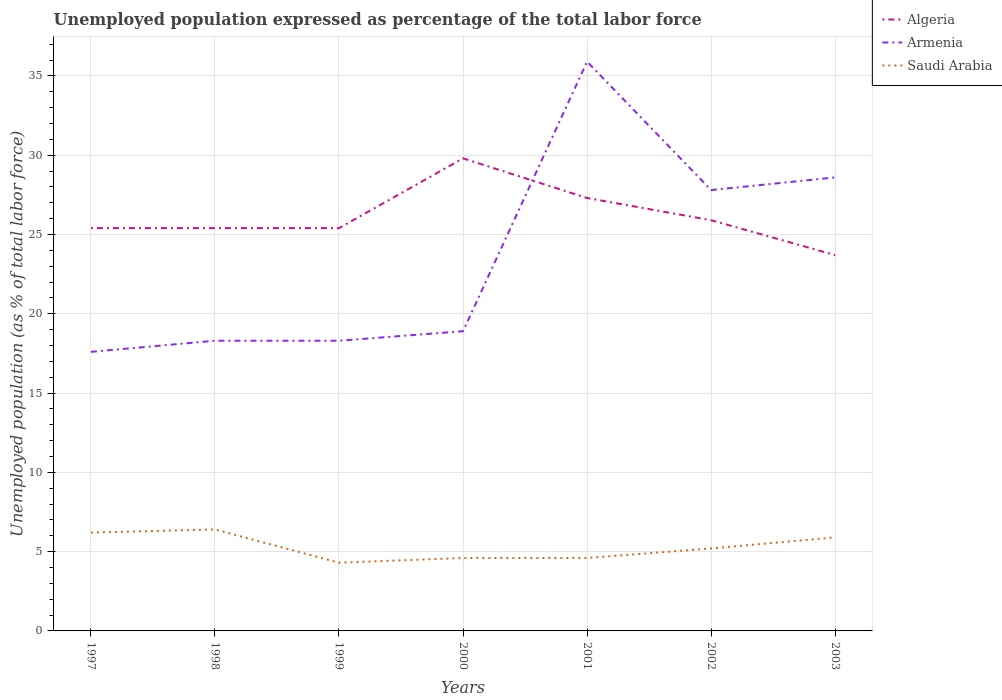Is the number of lines equal to the number of legend labels?
Give a very brief answer. Yes. Across all years, what is the maximum unemployment in in Algeria?
Offer a terse response. 23.7. What is the total unemployment in in Saudi Arabia in the graph?
Ensure brevity in your answer.  1. What is the difference between the highest and the second highest unemployment in in Saudi Arabia?
Make the answer very short. 2.1. How many lines are there?
Keep it short and to the point. 3. Where does the legend appear in the graph?
Ensure brevity in your answer.  Top right. How are the legend labels stacked?
Provide a short and direct response. Vertical. What is the title of the graph?
Make the answer very short. Unemployed population expressed as percentage of the total labor force. Does "Solomon Islands" appear as one of the legend labels in the graph?
Keep it short and to the point. No. What is the label or title of the Y-axis?
Offer a very short reply. Unemployed population (as % of total labor force). What is the Unemployed population (as % of total labor force) in Algeria in 1997?
Your answer should be compact. 25.4. What is the Unemployed population (as % of total labor force) of Armenia in 1997?
Make the answer very short. 17.6. What is the Unemployed population (as % of total labor force) of Saudi Arabia in 1997?
Make the answer very short. 6.2. What is the Unemployed population (as % of total labor force) of Algeria in 1998?
Keep it short and to the point. 25.4. What is the Unemployed population (as % of total labor force) of Armenia in 1998?
Your response must be concise. 18.3. What is the Unemployed population (as % of total labor force) of Saudi Arabia in 1998?
Provide a short and direct response. 6.4. What is the Unemployed population (as % of total labor force) of Algeria in 1999?
Your answer should be very brief. 25.4. What is the Unemployed population (as % of total labor force) of Armenia in 1999?
Your answer should be very brief. 18.3. What is the Unemployed population (as % of total labor force) in Saudi Arabia in 1999?
Make the answer very short. 4.3. What is the Unemployed population (as % of total labor force) in Algeria in 2000?
Offer a very short reply. 29.8. What is the Unemployed population (as % of total labor force) of Armenia in 2000?
Keep it short and to the point. 18.9. What is the Unemployed population (as % of total labor force) in Saudi Arabia in 2000?
Offer a terse response. 4.6. What is the Unemployed population (as % of total labor force) in Algeria in 2001?
Make the answer very short. 27.3. What is the Unemployed population (as % of total labor force) in Armenia in 2001?
Your answer should be very brief. 35.9. What is the Unemployed population (as % of total labor force) of Saudi Arabia in 2001?
Your response must be concise. 4.6. What is the Unemployed population (as % of total labor force) in Algeria in 2002?
Keep it short and to the point. 25.9. What is the Unemployed population (as % of total labor force) in Armenia in 2002?
Your answer should be very brief. 27.8. What is the Unemployed population (as % of total labor force) of Saudi Arabia in 2002?
Provide a succinct answer. 5.2. What is the Unemployed population (as % of total labor force) in Algeria in 2003?
Give a very brief answer. 23.7. What is the Unemployed population (as % of total labor force) in Armenia in 2003?
Offer a terse response. 28.6. What is the Unemployed population (as % of total labor force) in Saudi Arabia in 2003?
Make the answer very short. 5.9. Across all years, what is the maximum Unemployed population (as % of total labor force) of Algeria?
Give a very brief answer. 29.8. Across all years, what is the maximum Unemployed population (as % of total labor force) in Armenia?
Make the answer very short. 35.9. Across all years, what is the maximum Unemployed population (as % of total labor force) in Saudi Arabia?
Your answer should be very brief. 6.4. Across all years, what is the minimum Unemployed population (as % of total labor force) in Algeria?
Your answer should be very brief. 23.7. Across all years, what is the minimum Unemployed population (as % of total labor force) of Armenia?
Your answer should be compact. 17.6. Across all years, what is the minimum Unemployed population (as % of total labor force) of Saudi Arabia?
Ensure brevity in your answer.  4.3. What is the total Unemployed population (as % of total labor force) in Algeria in the graph?
Your answer should be compact. 182.9. What is the total Unemployed population (as % of total labor force) in Armenia in the graph?
Make the answer very short. 165.4. What is the total Unemployed population (as % of total labor force) of Saudi Arabia in the graph?
Give a very brief answer. 37.2. What is the difference between the Unemployed population (as % of total labor force) in Armenia in 1997 and that in 1998?
Offer a terse response. -0.7. What is the difference between the Unemployed population (as % of total labor force) of Saudi Arabia in 1997 and that in 1998?
Provide a succinct answer. -0.2. What is the difference between the Unemployed population (as % of total labor force) in Saudi Arabia in 1997 and that in 1999?
Your answer should be compact. 1.9. What is the difference between the Unemployed population (as % of total labor force) in Algeria in 1997 and that in 2000?
Offer a terse response. -4.4. What is the difference between the Unemployed population (as % of total labor force) of Armenia in 1997 and that in 2000?
Keep it short and to the point. -1.3. What is the difference between the Unemployed population (as % of total labor force) of Saudi Arabia in 1997 and that in 2000?
Provide a succinct answer. 1.6. What is the difference between the Unemployed population (as % of total labor force) in Armenia in 1997 and that in 2001?
Your response must be concise. -18.3. What is the difference between the Unemployed population (as % of total labor force) of Saudi Arabia in 1997 and that in 2001?
Keep it short and to the point. 1.6. What is the difference between the Unemployed population (as % of total labor force) of Algeria in 1997 and that in 2002?
Give a very brief answer. -0.5. What is the difference between the Unemployed population (as % of total labor force) of Algeria in 1997 and that in 2003?
Your answer should be compact. 1.7. What is the difference between the Unemployed population (as % of total labor force) in Algeria in 1998 and that in 2000?
Your response must be concise. -4.4. What is the difference between the Unemployed population (as % of total labor force) in Armenia in 1998 and that in 2001?
Provide a succinct answer. -17.6. What is the difference between the Unemployed population (as % of total labor force) of Algeria in 1998 and that in 2002?
Keep it short and to the point. -0.5. What is the difference between the Unemployed population (as % of total labor force) in Armenia in 1998 and that in 2002?
Your answer should be compact. -9.5. What is the difference between the Unemployed population (as % of total labor force) of Saudi Arabia in 1998 and that in 2002?
Ensure brevity in your answer.  1.2. What is the difference between the Unemployed population (as % of total labor force) of Armenia in 1998 and that in 2003?
Keep it short and to the point. -10.3. What is the difference between the Unemployed population (as % of total labor force) of Saudi Arabia in 1998 and that in 2003?
Offer a terse response. 0.5. What is the difference between the Unemployed population (as % of total labor force) in Algeria in 1999 and that in 2001?
Your response must be concise. -1.9. What is the difference between the Unemployed population (as % of total labor force) in Armenia in 1999 and that in 2001?
Give a very brief answer. -17.6. What is the difference between the Unemployed population (as % of total labor force) in Saudi Arabia in 1999 and that in 2001?
Offer a terse response. -0.3. What is the difference between the Unemployed population (as % of total labor force) of Armenia in 1999 and that in 2002?
Ensure brevity in your answer.  -9.5. What is the difference between the Unemployed population (as % of total labor force) of Saudi Arabia in 1999 and that in 2002?
Your answer should be compact. -0.9. What is the difference between the Unemployed population (as % of total labor force) of Algeria in 2000 and that in 2001?
Make the answer very short. 2.5. What is the difference between the Unemployed population (as % of total labor force) in Armenia in 2000 and that in 2001?
Provide a short and direct response. -17. What is the difference between the Unemployed population (as % of total labor force) in Algeria in 2000 and that in 2002?
Offer a very short reply. 3.9. What is the difference between the Unemployed population (as % of total labor force) in Armenia in 2000 and that in 2002?
Your answer should be very brief. -8.9. What is the difference between the Unemployed population (as % of total labor force) in Algeria in 2000 and that in 2003?
Your answer should be very brief. 6.1. What is the difference between the Unemployed population (as % of total labor force) of Saudi Arabia in 2000 and that in 2003?
Your answer should be compact. -1.3. What is the difference between the Unemployed population (as % of total labor force) of Algeria in 2001 and that in 2002?
Offer a terse response. 1.4. What is the difference between the Unemployed population (as % of total labor force) of Saudi Arabia in 2001 and that in 2002?
Your answer should be very brief. -0.6. What is the difference between the Unemployed population (as % of total labor force) of Armenia in 2001 and that in 2003?
Provide a succinct answer. 7.3. What is the difference between the Unemployed population (as % of total labor force) of Algeria in 1997 and the Unemployed population (as % of total labor force) of Armenia in 1998?
Ensure brevity in your answer.  7.1. What is the difference between the Unemployed population (as % of total labor force) of Algeria in 1997 and the Unemployed population (as % of total labor force) of Armenia in 1999?
Offer a very short reply. 7.1. What is the difference between the Unemployed population (as % of total labor force) in Algeria in 1997 and the Unemployed population (as % of total labor force) in Saudi Arabia in 1999?
Give a very brief answer. 21.1. What is the difference between the Unemployed population (as % of total labor force) of Algeria in 1997 and the Unemployed population (as % of total labor force) of Saudi Arabia in 2000?
Make the answer very short. 20.8. What is the difference between the Unemployed population (as % of total labor force) in Armenia in 1997 and the Unemployed population (as % of total labor force) in Saudi Arabia in 2000?
Keep it short and to the point. 13. What is the difference between the Unemployed population (as % of total labor force) in Algeria in 1997 and the Unemployed population (as % of total labor force) in Saudi Arabia in 2001?
Offer a very short reply. 20.8. What is the difference between the Unemployed population (as % of total labor force) of Algeria in 1997 and the Unemployed population (as % of total labor force) of Saudi Arabia in 2002?
Your answer should be very brief. 20.2. What is the difference between the Unemployed population (as % of total labor force) in Algeria in 1997 and the Unemployed population (as % of total labor force) in Saudi Arabia in 2003?
Offer a very short reply. 19.5. What is the difference between the Unemployed population (as % of total labor force) in Algeria in 1998 and the Unemployed population (as % of total labor force) in Armenia in 1999?
Your answer should be very brief. 7.1. What is the difference between the Unemployed population (as % of total labor force) in Algeria in 1998 and the Unemployed population (as % of total labor force) in Saudi Arabia in 1999?
Offer a terse response. 21.1. What is the difference between the Unemployed population (as % of total labor force) of Algeria in 1998 and the Unemployed population (as % of total labor force) of Saudi Arabia in 2000?
Your answer should be compact. 20.8. What is the difference between the Unemployed population (as % of total labor force) in Armenia in 1998 and the Unemployed population (as % of total labor force) in Saudi Arabia in 2000?
Give a very brief answer. 13.7. What is the difference between the Unemployed population (as % of total labor force) of Algeria in 1998 and the Unemployed population (as % of total labor force) of Armenia in 2001?
Ensure brevity in your answer.  -10.5. What is the difference between the Unemployed population (as % of total labor force) in Algeria in 1998 and the Unemployed population (as % of total labor force) in Saudi Arabia in 2001?
Your response must be concise. 20.8. What is the difference between the Unemployed population (as % of total labor force) in Armenia in 1998 and the Unemployed population (as % of total labor force) in Saudi Arabia in 2001?
Offer a terse response. 13.7. What is the difference between the Unemployed population (as % of total labor force) of Algeria in 1998 and the Unemployed population (as % of total labor force) of Armenia in 2002?
Your response must be concise. -2.4. What is the difference between the Unemployed population (as % of total labor force) in Algeria in 1998 and the Unemployed population (as % of total labor force) in Saudi Arabia in 2002?
Provide a succinct answer. 20.2. What is the difference between the Unemployed population (as % of total labor force) of Algeria in 1998 and the Unemployed population (as % of total labor force) of Armenia in 2003?
Keep it short and to the point. -3.2. What is the difference between the Unemployed population (as % of total labor force) in Algeria in 1998 and the Unemployed population (as % of total labor force) in Saudi Arabia in 2003?
Keep it short and to the point. 19.5. What is the difference between the Unemployed population (as % of total labor force) in Armenia in 1998 and the Unemployed population (as % of total labor force) in Saudi Arabia in 2003?
Keep it short and to the point. 12.4. What is the difference between the Unemployed population (as % of total labor force) of Algeria in 1999 and the Unemployed population (as % of total labor force) of Saudi Arabia in 2000?
Give a very brief answer. 20.8. What is the difference between the Unemployed population (as % of total labor force) of Armenia in 1999 and the Unemployed population (as % of total labor force) of Saudi Arabia in 2000?
Offer a very short reply. 13.7. What is the difference between the Unemployed population (as % of total labor force) in Algeria in 1999 and the Unemployed population (as % of total labor force) in Armenia in 2001?
Provide a short and direct response. -10.5. What is the difference between the Unemployed population (as % of total labor force) in Algeria in 1999 and the Unemployed population (as % of total labor force) in Saudi Arabia in 2001?
Provide a short and direct response. 20.8. What is the difference between the Unemployed population (as % of total labor force) of Algeria in 1999 and the Unemployed population (as % of total labor force) of Saudi Arabia in 2002?
Give a very brief answer. 20.2. What is the difference between the Unemployed population (as % of total labor force) of Algeria in 2000 and the Unemployed population (as % of total labor force) of Saudi Arabia in 2001?
Provide a short and direct response. 25.2. What is the difference between the Unemployed population (as % of total labor force) of Armenia in 2000 and the Unemployed population (as % of total labor force) of Saudi Arabia in 2001?
Provide a succinct answer. 14.3. What is the difference between the Unemployed population (as % of total labor force) in Algeria in 2000 and the Unemployed population (as % of total labor force) in Saudi Arabia in 2002?
Make the answer very short. 24.6. What is the difference between the Unemployed population (as % of total labor force) in Armenia in 2000 and the Unemployed population (as % of total labor force) in Saudi Arabia in 2002?
Keep it short and to the point. 13.7. What is the difference between the Unemployed population (as % of total labor force) of Algeria in 2000 and the Unemployed population (as % of total labor force) of Saudi Arabia in 2003?
Make the answer very short. 23.9. What is the difference between the Unemployed population (as % of total labor force) of Armenia in 2000 and the Unemployed population (as % of total labor force) of Saudi Arabia in 2003?
Provide a succinct answer. 13. What is the difference between the Unemployed population (as % of total labor force) in Algeria in 2001 and the Unemployed population (as % of total labor force) in Armenia in 2002?
Your response must be concise. -0.5. What is the difference between the Unemployed population (as % of total labor force) in Algeria in 2001 and the Unemployed population (as % of total labor force) in Saudi Arabia in 2002?
Give a very brief answer. 22.1. What is the difference between the Unemployed population (as % of total labor force) of Armenia in 2001 and the Unemployed population (as % of total labor force) of Saudi Arabia in 2002?
Offer a terse response. 30.7. What is the difference between the Unemployed population (as % of total labor force) of Algeria in 2001 and the Unemployed population (as % of total labor force) of Armenia in 2003?
Ensure brevity in your answer.  -1.3. What is the difference between the Unemployed population (as % of total labor force) of Algeria in 2001 and the Unemployed population (as % of total labor force) of Saudi Arabia in 2003?
Provide a short and direct response. 21.4. What is the difference between the Unemployed population (as % of total labor force) of Algeria in 2002 and the Unemployed population (as % of total labor force) of Armenia in 2003?
Your response must be concise. -2.7. What is the difference between the Unemployed population (as % of total labor force) in Algeria in 2002 and the Unemployed population (as % of total labor force) in Saudi Arabia in 2003?
Your response must be concise. 20. What is the difference between the Unemployed population (as % of total labor force) of Armenia in 2002 and the Unemployed population (as % of total labor force) of Saudi Arabia in 2003?
Provide a short and direct response. 21.9. What is the average Unemployed population (as % of total labor force) of Algeria per year?
Keep it short and to the point. 26.13. What is the average Unemployed population (as % of total labor force) of Armenia per year?
Provide a succinct answer. 23.63. What is the average Unemployed population (as % of total labor force) of Saudi Arabia per year?
Your answer should be compact. 5.31. In the year 1998, what is the difference between the Unemployed population (as % of total labor force) in Armenia and Unemployed population (as % of total labor force) in Saudi Arabia?
Your response must be concise. 11.9. In the year 1999, what is the difference between the Unemployed population (as % of total labor force) of Algeria and Unemployed population (as % of total labor force) of Armenia?
Offer a terse response. 7.1. In the year 1999, what is the difference between the Unemployed population (as % of total labor force) of Algeria and Unemployed population (as % of total labor force) of Saudi Arabia?
Give a very brief answer. 21.1. In the year 1999, what is the difference between the Unemployed population (as % of total labor force) in Armenia and Unemployed population (as % of total labor force) in Saudi Arabia?
Provide a succinct answer. 14. In the year 2000, what is the difference between the Unemployed population (as % of total labor force) of Algeria and Unemployed population (as % of total labor force) of Saudi Arabia?
Provide a short and direct response. 25.2. In the year 2001, what is the difference between the Unemployed population (as % of total labor force) of Algeria and Unemployed population (as % of total labor force) of Armenia?
Your response must be concise. -8.6. In the year 2001, what is the difference between the Unemployed population (as % of total labor force) of Algeria and Unemployed population (as % of total labor force) of Saudi Arabia?
Give a very brief answer. 22.7. In the year 2001, what is the difference between the Unemployed population (as % of total labor force) of Armenia and Unemployed population (as % of total labor force) of Saudi Arabia?
Provide a succinct answer. 31.3. In the year 2002, what is the difference between the Unemployed population (as % of total labor force) in Algeria and Unemployed population (as % of total labor force) in Armenia?
Your response must be concise. -1.9. In the year 2002, what is the difference between the Unemployed population (as % of total labor force) in Algeria and Unemployed population (as % of total labor force) in Saudi Arabia?
Make the answer very short. 20.7. In the year 2002, what is the difference between the Unemployed population (as % of total labor force) of Armenia and Unemployed population (as % of total labor force) of Saudi Arabia?
Give a very brief answer. 22.6. In the year 2003, what is the difference between the Unemployed population (as % of total labor force) of Algeria and Unemployed population (as % of total labor force) of Armenia?
Ensure brevity in your answer.  -4.9. In the year 2003, what is the difference between the Unemployed population (as % of total labor force) in Algeria and Unemployed population (as % of total labor force) in Saudi Arabia?
Offer a terse response. 17.8. In the year 2003, what is the difference between the Unemployed population (as % of total labor force) of Armenia and Unemployed population (as % of total labor force) of Saudi Arabia?
Make the answer very short. 22.7. What is the ratio of the Unemployed population (as % of total labor force) of Armenia in 1997 to that in 1998?
Your answer should be compact. 0.96. What is the ratio of the Unemployed population (as % of total labor force) in Saudi Arabia in 1997 to that in 1998?
Make the answer very short. 0.97. What is the ratio of the Unemployed population (as % of total labor force) of Algeria in 1997 to that in 1999?
Give a very brief answer. 1. What is the ratio of the Unemployed population (as % of total labor force) of Armenia in 1997 to that in 1999?
Your answer should be very brief. 0.96. What is the ratio of the Unemployed population (as % of total labor force) in Saudi Arabia in 1997 to that in 1999?
Provide a short and direct response. 1.44. What is the ratio of the Unemployed population (as % of total labor force) in Algeria in 1997 to that in 2000?
Your answer should be very brief. 0.85. What is the ratio of the Unemployed population (as % of total labor force) of Armenia in 1997 to that in 2000?
Give a very brief answer. 0.93. What is the ratio of the Unemployed population (as % of total labor force) of Saudi Arabia in 1997 to that in 2000?
Offer a terse response. 1.35. What is the ratio of the Unemployed population (as % of total labor force) in Algeria in 1997 to that in 2001?
Offer a terse response. 0.93. What is the ratio of the Unemployed population (as % of total labor force) of Armenia in 1997 to that in 2001?
Your answer should be compact. 0.49. What is the ratio of the Unemployed population (as % of total labor force) of Saudi Arabia in 1997 to that in 2001?
Offer a very short reply. 1.35. What is the ratio of the Unemployed population (as % of total labor force) in Algeria in 1997 to that in 2002?
Make the answer very short. 0.98. What is the ratio of the Unemployed population (as % of total labor force) of Armenia in 1997 to that in 2002?
Offer a very short reply. 0.63. What is the ratio of the Unemployed population (as % of total labor force) of Saudi Arabia in 1997 to that in 2002?
Give a very brief answer. 1.19. What is the ratio of the Unemployed population (as % of total labor force) in Algeria in 1997 to that in 2003?
Offer a very short reply. 1.07. What is the ratio of the Unemployed population (as % of total labor force) of Armenia in 1997 to that in 2003?
Offer a terse response. 0.62. What is the ratio of the Unemployed population (as % of total labor force) of Saudi Arabia in 1997 to that in 2003?
Your response must be concise. 1.05. What is the ratio of the Unemployed population (as % of total labor force) in Algeria in 1998 to that in 1999?
Ensure brevity in your answer.  1. What is the ratio of the Unemployed population (as % of total labor force) in Saudi Arabia in 1998 to that in 1999?
Ensure brevity in your answer.  1.49. What is the ratio of the Unemployed population (as % of total labor force) of Algeria in 1998 to that in 2000?
Offer a terse response. 0.85. What is the ratio of the Unemployed population (as % of total labor force) of Armenia in 1998 to that in 2000?
Your answer should be very brief. 0.97. What is the ratio of the Unemployed population (as % of total labor force) of Saudi Arabia in 1998 to that in 2000?
Offer a very short reply. 1.39. What is the ratio of the Unemployed population (as % of total labor force) in Algeria in 1998 to that in 2001?
Provide a short and direct response. 0.93. What is the ratio of the Unemployed population (as % of total labor force) of Armenia in 1998 to that in 2001?
Provide a succinct answer. 0.51. What is the ratio of the Unemployed population (as % of total labor force) of Saudi Arabia in 1998 to that in 2001?
Your response must be concise. 1.39. What is the ratio of the Unemployed population (as % of total labor force) in Algeria in 1998 to that in 2002?
Offer a terse response. 0.98. What is the ratio of the Unemployed population (as % of total labor force) of Armenia in 1998 to that in 2002?
Provide a short and direct response. 0.66. What is the ratio of the Unemployed population (as % of total labor force) of Saudi Arabia in 1998 to that in 2002?
Provide a succinct answer. 1.23. What is the ratio of the Unemployed population (as % of total labor force) of Algeria in 1998 to that in 2003?
Provide a short and direct response. 1.07. What is the ratio of the Unemployed population (as % of total labor force) of Armenia in 1998 to that in 2003?
Offer a very short reply. 0.64. What is the ratio of the Unemployed population (as % of total labor force) of Saudi Arabia in 1998 to that in 2003?
Provide a succinct answer. 1.08. What is the ratio of the Unemployed population (as % of total labor force) in Algeria in 1999 to that in 2000?
Your response must be concise. 0.85. What is the ratio of the Unemployed population (as % of total labor force) in Armenia in 1999 to that in 2000?
Give a very brief answer. 0.97. What is the ratio of the Unemployed population (as % of total labor force) of Saudi Arabia in 1999 to that in 2000?
Provide a short and direct response. 0.93. What is the ratio of the Unemployed population (as % of total labor force) of Algeria in 1999 to that in 2001?
Offer a terse response. 0.93. What is the ratio of the Unemployed population (as % of total labor force) in Armenia in 1999 to that in 2001?
Provide a succinct answer. 0.51. What is the ratio of the Unemployed population (as % of total labor force) in Saudi Arabia in 1999 to that in 2001?
Give a very brief answer. 0.93. What is the ratio of the Unemployed population (as % of total labor force) in Algeria in 1999 to that in 2002?
Keep it short and to the point. 0.98. What is the ratio of the Unemployed population (as % of total labor force) in Armenia in 1999 to that in 2002?
Provide a short and direct response. 0.66. What is the ratio of the Unemployed population (as % of total labor force) in Saudi Arabia in 1999 to that in 2002?
Your answer should be compact. 0.83. What is the ratio of the Unemployed population (as % of total labor force) of Algeria in 1999 to that in 2003?
Provide a succinct answer. 1.07. What is the ratio of the Unemployed population (as % of total labor force) in Armenia in 1999 to that in 2003?
Make the answer very short. 0.64. What is the ratio of the Unemployed population (as % of total labor force) in Saudi Arabia in 1999 to that in 2003?
Offer a terse response. 0.73. What is the ratio of the Unemployed population (as % of total labor force) of Algeria in 2000 to that in 2001?
Your answer should be compact. 1.09. What is the ratio of the Unemployed population (as % of total labor force) in Armenia in 2000 to that in 2001?
Your answer should be very brief. 0.53. What is the ratio of the Unemployed population (as % of total labor force) in Saudi Arabia in 2000 to that in 2001?
Provide a succinct answer. 1. What is the ratio of the Unemployed population (as % of total labor force) of Algeria in 2000 to that in 2002?
Your answer should be very brief. 1.15. What is the ratio of the Unemployed population (as % of total labor force) of Armenia in 2000 to that in 2002?
Provide a short and direct response. 0.68. What is the ratio of the Unemployed population (as % of total labor force) in Saudi Arabia in 2000 to that in 2002?
Offer a very short reply. 0.88. What is the ratio of the Unemployed population (as % of total labor force) in Algeria in 2000 to that in 2003?
Provide a succinct answer. 1.26. What is the ratio of the Unemployed population (as % of total labor force) in Armenia in 2000 to that in 2003?
Offer a terse response. 0.66. What is the ratio of the Unemployed population (as % of total labor force) of Saudi Arabia in 2000 to that in 2003?
Your answer should be compact. 0.78. What is the ratio of the Unemployed population (as % of total labor force) of Algeria in 2001 to that in 2002?
Make the answer very short. 1.05. What is the ratio of the Unemployed population (as % of total labor force) of Armenia in 2001 to that in 2002?
Keep it short and to the point. 1.29. What is the ratio of the Unemployed population (as % of total labor force) of Saudi Arabia in 2001 to that in 2002?
Give a very brief answer. 0.88. What is the ratio of the Unemployed population (as % of total labor force) in Algeria in 2001 to that in 2003?
Give a very brief answer. 1.15. What is the ratio of the Unemployed population (as % of total labor force) of Armenia in 2001 to that in 2003?
Make the answer very short. 1.26. What is the ratio of the Unemployed population (as % of total labor force) of Saudi Arabia in 2001 to that in 2003?
Ensure brevity in your answer.  0.78. What is the ratio of the Unemployed population (as % of total labor force) of Algeria in 2002 to that in 2003?
Provide a short and direct response. 1.09. What is the ratio of the Unemployed population (as % of total labor force) in Saudi Arabia in 2002 to that in 2003?
Your answer should be very brief. 0.88. What is the difference between the highest and the second highest Unemployed population (as % of total labor force) of Algeria?
Your response must be concise. 2.5. What is the difference between the highest and the second highest Unemployed population (as % of total labor force) of Saudi Arabia?
Your answer should be compact. 0.2. What is the difference between the highest and the lowest Unemployed population (as % of total labor force) in Algeria?
Ensure brevity in your answer.  6.1. What is the difference between the highest and the lowest Unemployed population (as % of total labor force) in Armenia?
Your response must be concise. 18.3. What is the difference between the highest and the lowest Unemployed population (as % of total labor force) of Saudi Arabia?
Keep it short and to the point. 2.1. 